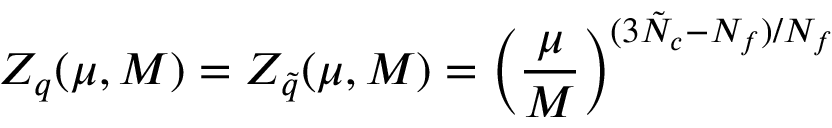<formula> <loc_0><loc_0><loc_500><loc_500>Z _ { q } ( \mu , M ) = Z _ { \tilde { q } } ( \mu , M ) = \left ( \frac { \mu } { M } \right ) ^ { ( 3 \tilde { N } _ { c } - N _ { f } ) / N _ { f } }</formula> 